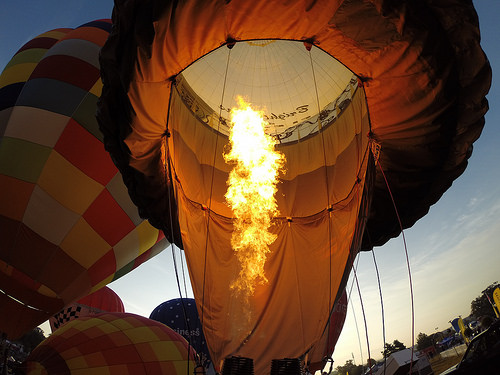<image>
Is there a fire on the cloth? Yes. Looking at the image, I can see the fire is positioned on top of the cloth, with the cloth providing support. 